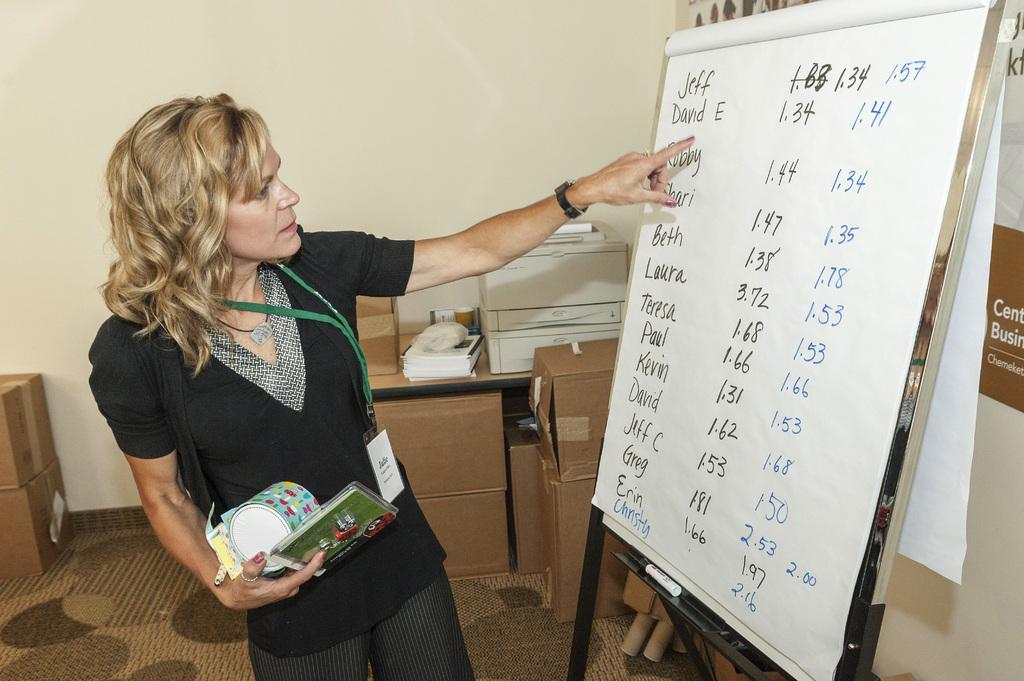Provide a one-sentence caption for the provided image. The first name in a list on a large white paper is Jeff. 